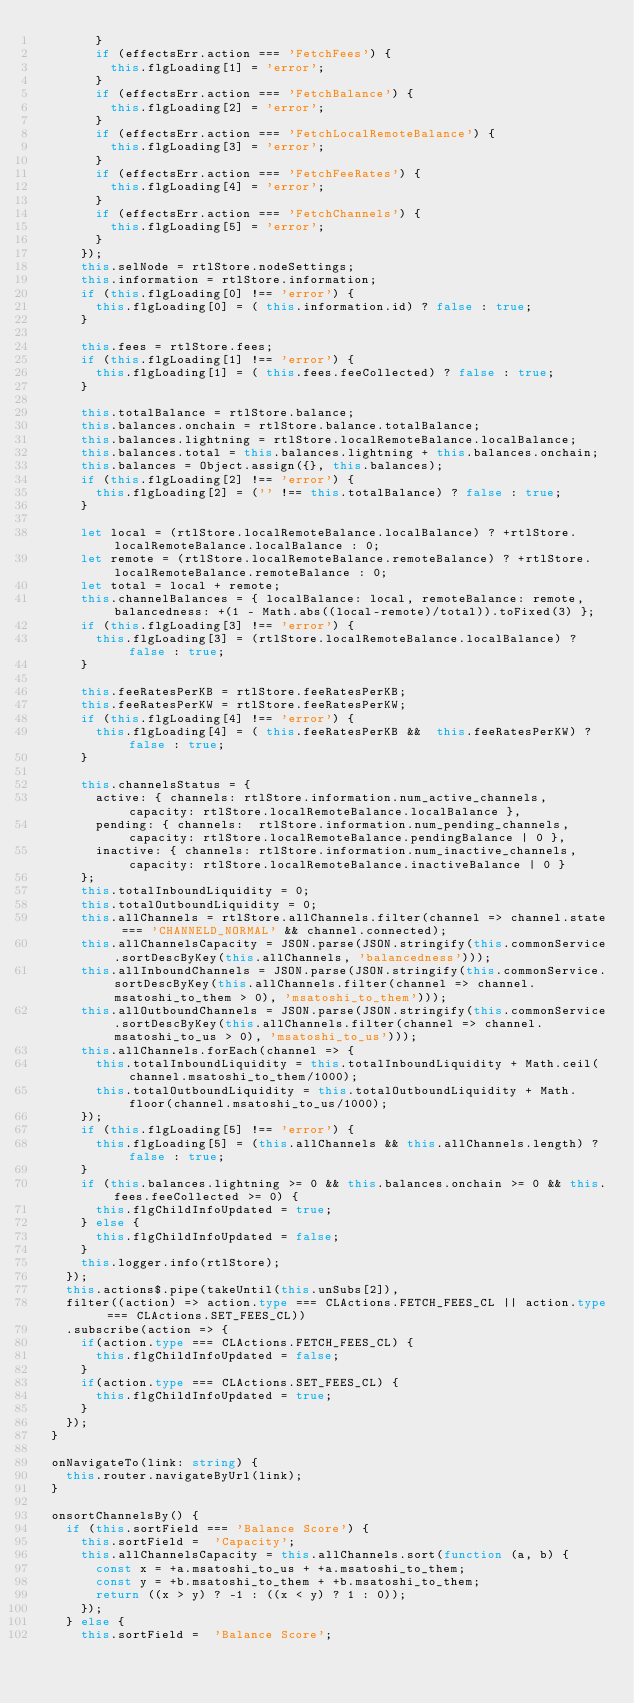Convert code to text. <code><loc_0><loc_0><loc_500><loc_500><_TypeScript_>        }
        if (effectsErr.action === 'FetchFees') {
          this.flgLoading[1] = 'error';
        }
        if (effectsErr.action === 'FetchBalance') {
          this.flgLoading[2] = 'error';
        }
        if (effectsErr.action === 'FetchLocalRemoteBalance') {
          this.flgLoading[3] = 'error';
        }
        if (effectsErr.action === 'FetchFeeRates') {
          this.flgLoading[4] = 'error';
        }
        if (effectsErr.action === 'FetchChannels') {
          this.flgLoading[5] = 'error';
        }
      });
      this.selNode = rtlStore.nodeSettings;
      this.information = rtlStore.information;
      if (this.flgLoading[0] !== 'error') {
        this.flgLoading[0] = ( this.information.id) ? false : true;
      }

      this.fees = rtlStore.fees;
      if (this.flgLoading[1] !== 'error') {
        this.flgLoading[1] = ( this.fees.feeCollected) ? false : true;
      }

      this.totalBalance = rtlStore.balance;
      this.balances.onchain = rtlStore.balance.totalBalance;
      this.balances.lightning = rtlStore.localRemoteBalance.localBalance;
      this.balances.total = this.balances.lightning + this.balances.onchain;
      this.balances = Object.assign({}, this.balances);
      if (this.flgLoading[2] !== 'error') {
        this.flgLoading[2] = ('' !== this.totalBalance) ? false : true;
      }

      let local = (rtlStore.localRemoteBalance.localBalance) ? +rtlStore.localRemoteBalance.localBalance : 0;
      let remote = (rtlStore.localRemoteBalance.remoteBalance) ? +rtlStore.localRemoteBalance.remoteBalance : 0;
      let total = local + remote;
      this.channelBalances = { localBalance: local, remoteBalance: remote, balancedness: +(1 - Math.abs((local-remote)/total)).toFixed(3) };
      if (this.flgLoading[3] !== 'error') {
        this.flgLoading[3] = (rtlStore.localRemoteBalance.localBalance) ? false : true;
      }

      this.feeRatesPerKB = rtlStore.feeRatesPerKB;
      this.feeRatesPerKW = rtlStore.feeRatesPerKW;
      if (this.flgLoading[4] !== 'error') {
        this.flgLoading[4] = ( this.feeRatesPerKB &&  this.feeRatesPerKW) ? false : true;
      }

      this.channelsStatus = {
        active: { channels: rtlStore.information.num_active_channels, capacity: rtlStore.localRemoteBalance.localBalance },
        pending: { channels:  rtlStore.information.num_pending_channels, capacity: rtlStore.localRemoteBalance.pendingBalance | 0 },
        inactive: { channels: rtlStore.information.num_inactive_channels, capacity: rtlStore.localRemoteBalance.inactiveBalance | 0 }
      };
      this.totalInboundLiquidity = 0;
      this.totalOutboundLiquidity = 0;
      this.allChannels = rtlStore.allChannels.filter(channel => channel.state === 'CHANNELD_NORMAL' && channel.connected);
      this.allChannelsCapacity = JSON.parse(JSON.stringify(this.commonService.sortDescByKey(this.allChannels, 'balancedness')));
      this.allInboundChannels = JSON.parse(JSON.stringify(this.commonService.sortDescByKey(this.allChannels.filter(channel => channel.msatoshi_to_them > 0), 'msatoshi_to_them')));
      this.allOutboundChannels = JSON.parse(JSON.stringify(this.commonService.sortDescByKey(this.allChannels.filter(channel => channel.msatoshi_to_us > 0), 'msatoshi_to_us')));
      this.allChannels.forEach(channel => {
        this.totalInboundLiquidity = this.totalInboundLiquidity + Math.ceil(channel.msatoshi_to_them/1000);
        this.totalOutboundLiquidity = this.totalOutboundLiquidity + Math.floor(channel.msatoshi_to_us/1000);
      });
      if (this.flgLoading[5] !== 'error') {
        this.flgLoading[5] = (this.allChannels && this.allChannels.length) ? false : true;
      }      
      if (this.balances.lightning >= 0 && this.balances.onchain >= 0 && this.fees.feeCollected >= 0) {
        this.flgChildInfoUpdated = true;
      } else {
        this.flgChildInfoUpdated = false;
      }
      this.logger.info(rtlStore);
    });
    this.actions$.pipe(takeUntil(this.unSubs[2]),
    filter((action) => action.type === CLActions.FETCH_FEES_CL || action.type === CLActions.SET_FEES_CL))
    .subscribe(action => {
      if(action.type === CLActions.FETCH_FEES_CL) {
        this.flgChildInfoUpdated = false;
      }
      if(action.type === CLActions.SET_FEES_CL) {
        this.flgChildInfoUpdated = true;
      }
    });
  }

  onNavigateTo(link: string) {
    this.router.navigateByUrl(link);
  }

  onsortChannelsBy() {
    if (this.sortField === 'Balance Score') {
      this.sortField =  'Capacity';
      this.allChannelsCapacity = this.allChannels.sort(function (a, b) {
        const x = +a.msatoshi_to_us + +a.msatoshi_to_them;
        const y = +b.msatoshi_to_them + +b.msatoshi_to_them;
        return ((x > y) ? -1 : ((x < y) ? 1 : 0));
      });
    } else {
      this.sortField =  'Balance Score';</code> 